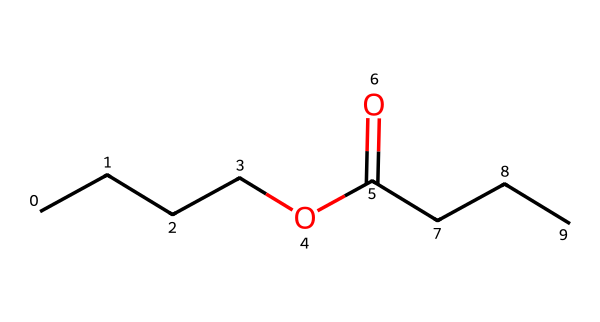What is the molecular formula of butyl butyrate? The molecular formula can be derived from the SMILES representation by identifying the carbon (C), hydrogen (H), and oxygen (O) atoms. In the structure, there are 8 carbon atoms, 16 hydrogen atoms, and 2 oxygen atoms. This leads to the molecular formula C8H16O2.
Answer: C8H16O2 How many carbon atoms are in butyl butyrate? Counting from the SMILES representation, there are 8 instances of 'C', indicating 8 carbon atoms in total.
Answer: 8 What functional group is present in butyl butyrate? The presence of the "C(=O)" part of the SMILES indicates a carbonyl group (C=O), which signifies that the compound is an ester.
Answer: ester What type of reaction would lead to the formation of butyl butyrate? Butyl butyrate is formed through a condensation reaction known as esterification, which involves the reaction of an alcohol (butanol) and a carboxylic acid (butanoic acid).
Answer: esterification How many oxygen atoms are present in butyl butyrate? From the SMILES representation, there are 2 'O' instances, indicating that there are 2 oxygen atoms in butyl butyrate.
Answer: 2 What is the characteristic scent associated with butyl butyrate? Butyl butyrate is known for its pineapple scent, which is associated with its use as a flavoring agent.
Answer: pineapple 